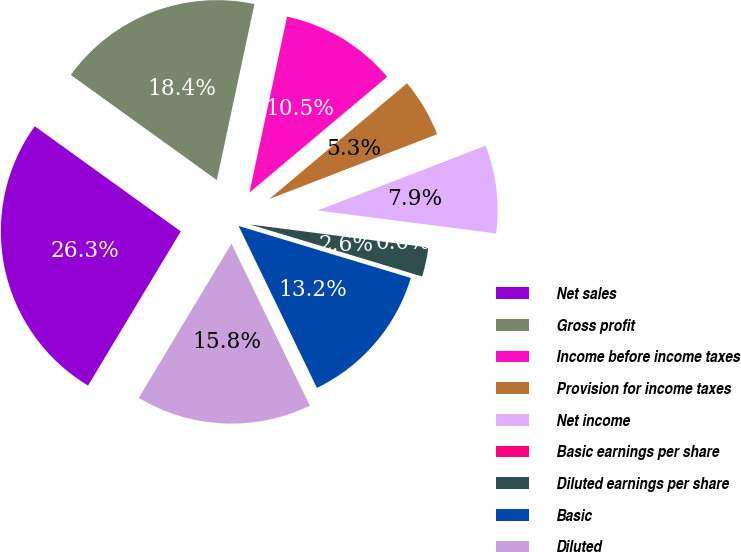Convert chart to OTSL. <chart><loc_0><loc_0><loc_500><loc_500><pie_chart><fcel>Net sales<fcel>Gross profit<fcel>Income before income taxes<fcel>Provision for income taxes<fcel>Net income<fcel>Basic earnings per share<fcel>Diluted earnings per share<fcel>Basic<fcel>Diluted<nl><fcel>26.31%<fcel>18.42%<fcel>10.53%<fcel>5.26%<fcel>7.9%<fcel>0.0%<fcel>2.63%<fcel>13.16%<fcel>15.79%<nl></chart> 